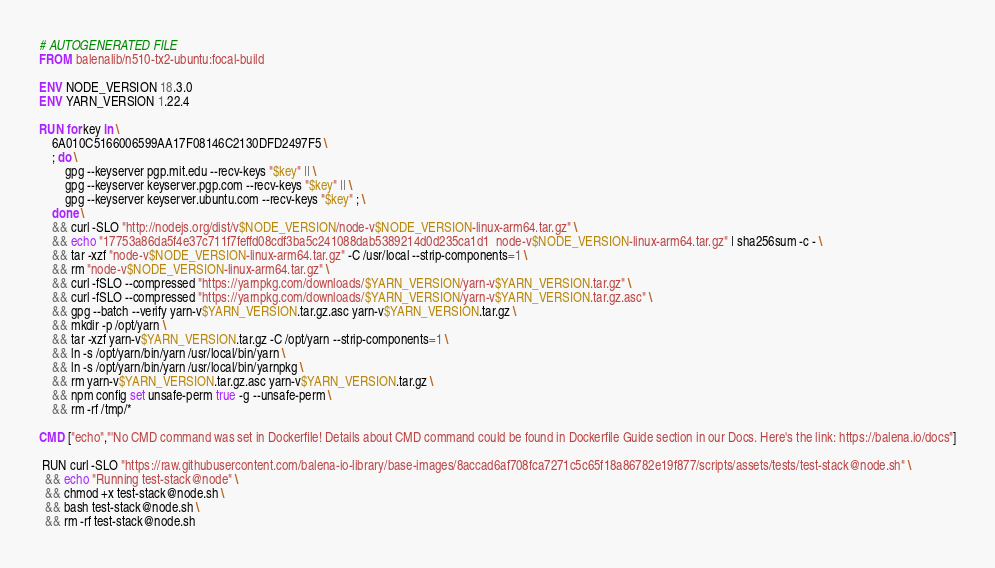Convert code to text. <code><loc_0><loc_0><loc_500><loc_500><_Dockerfile_># AUTOGENERATED FILE
FROM balenalib/n510-tx2-ubuntu:focal-build

ENV NODE_VERSION 18.3.0
ENV YARN_VERSION 1.22.4

RUN for key in \
	6A010C5166006599AA17F08146C2130DFD2497F5 \
	; do \
		gpg --keyserver pgp.mit.edu --recv-keys "$key" || \
		gpg --keyserver keyserver.pgp.com --recv-keys "$key" || \
		gpg --keyserver keyserver.ubuntu.com --recv-keys "$key" ; \
	done \
	&& curl -SLO "http://nodejs.org/dist/v$NODE_VERSION/node-v$NODE_VERSION-linux-arm64.tar.gz" \
	&& echo "17753a86da5f4e37c711f7feffd08cdf3ba5c241088dab5389214d0d235ca1d1  node-v$NODE_VERSION-linux-arm64.tar.gz" | sha256sum -c - \
	&& tar -xzf "node-v$NODE_VERSION-linux-arm64.tar.gz" -C /usr/local --strip-components=1 \
	&& rm "node-v$NODE_VERSION-linux-arm64.tar.gz" \
	&& curl -fSLO --compressed "https://yarnpkg.com/downloads/$YARN_VERSION/yarn-v$YARN_VERSION.tar.gz" \
	&& curl -fSLO --compressed "https://yarnpkg.com/downloads/$YARN_VERSION/yarn-v$YARN_VERSION.tar.gz.asc" \
	&& gpg --batch --verify yarn-v$YARN_VERSION.tar.gz.asc yarn-v$YARN_VERSION.tar.gz \
	&& mkdir -p /opt/yarn \
	&& tar -xzf yarn-v$YARN_VERSION.tar.gz -C /opt/yarn --strip-components=1 \
	&& ln -s /opt/yarn/bin/yarn /usr/local/bin/yarn \
	&& ln -s /opt/yarn/bin/yarn /usr/local/bin/yarnpkg \
	&& rm yarn-v$YARN_VERSION.tar.gz.asc yarn-v$YARN_VERSION.tar.gz \
	&& npm config set unsafe-perm true -g --unsafe-perm \
	&& rm -rf /tmp/*

CMD ["echo","'No CMD command was set in Dockerfile! Details about CMD command could be found in Dockerfile Guide section in our Docs. Here's the link: https://balena.io/docs"]

 RUN curl -SLO "https://raw.githubusercontent.com/balena-io-library/base-images/8accad6af708fca7271c5c65f18a86782e19f877/scripts/assets/tests/test-stack@node.sh" \
  && echo "Running test-stack@node" \
  && chmod +x test-stack@node.sh \
  && bash test-stack@node.sh \
  && rm -rf test-stack@node.sh 
</code> 